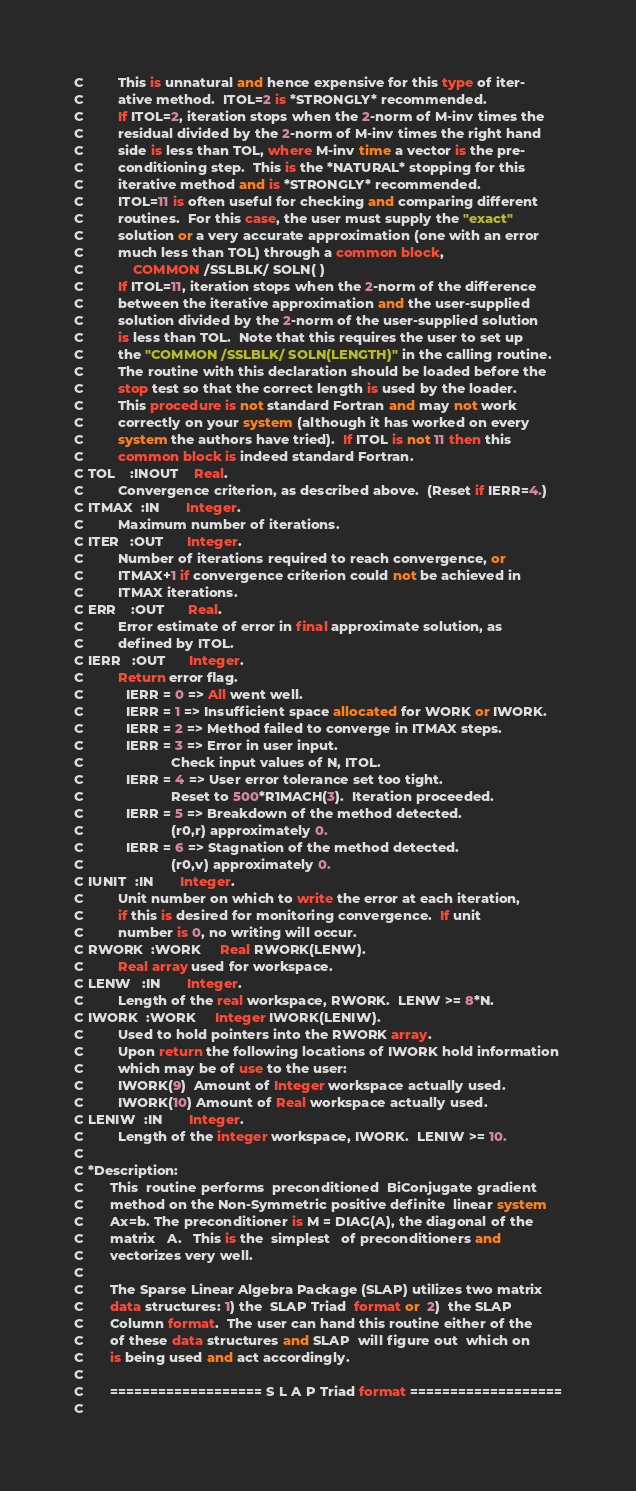Convert code to text. <code><loc_0><loc_0><loc_500><loc_500><_FORTRAN_>C         This is unnatural and hence expensive for this type of iter-
C         ative method.  ITOL=2 is *STRONGLY* recommended.
C         If ITOL=2, iteration stops when the 2-norm of M-inv times the
C         residual divided by the 2-norm of M-inv times the right hand
C         side is less than TOL, where M-inv time a vector is the pre-
C         conditioning step.  This is the *NATURAL* stopping for this
C         iterative method and is *STRONGLY* recommended.
C         ITOL=11 is often useful for checking and comparing different
C         routines.  For this case, the user must supply the "exact"
C         solution or a very accurate approximation (one with an error
C         much less than TOL) through a common block,
C             COMMON /SSLBLK/ SOLN( )
C         If ITOL=11, iteration stops when the 2-norm of the difference
C         between the iterative approximation and the user-supplied
C         solution divided by the 2-norm of the user-supplied solution
C         is less than TOL.  Note that this requires the user to set up
C         the "COMMON /SSLBLK/ SOLN(LENGTH)" in the calling routine.
C         The routine with this declaration should be loaded before the
C         stop test so that the correct length is used by the loader.
C         This procedure is not standard Fortran and may not work
C         correctly on your system (although it has worked on every
C         system the authors have tried).  If ITOL is not 11 then this
C         common block is indeed standard Fortran.
C TOL    :INOUT    Real.
C         Convergence criterion, as described above.  (Reset if IERR=4.)
C ITMAX  :IN       Integer.
C         Maximum number of iterations.
C ITER   :OUT      Integer.
C         Number of iterations required to reach convergence, or
C         ITMAX+1 if convergence criterion could not be achieved in
C         ITMAX iterations.
C ERR    :OUT      Real.
C         Error estimate of error in final approximate solution, as
C         defined by ITOL.
C IERR   :OUT      Integer.
C         Return error flag.
C           IERR = 0 => All went well.
C           IERR = 1 => Insufficient space allocated for WORK or IWORK.
C           IERR = 2 => Method failed to converge in ITMAX steps.
C           IERR = 3 => Error in user input.
C                       Check input values of N, ITOL.
C           IERR = 4 => User error tolerance set too tight.
C                       Reset to 500*R1MACH(3).  Iteration proceeded.
C           IERR = 5 => Breakdown of the method detected.
C                       (r0,r) approximately 0.
C           IERR = 6 => Stagnation of the method detected.
C                       (r0,v) approximately 0.
C IUNIT  :IN       Integer.
C         Unit number on which to write the error at each iteration,
C         if this is desired for monitoring convergence.  If unit
C         number is 0, no writing will occur.
C RWORK  :WORK     Real RWORK(LENW).
C         Real array used for workspace.
C LENW   :IN       Integer.
C         Length of the real workspace, RWORK.  LENW >= 8*N.
C IWORK  :WORK     Integer IWORK(LENIW).
C         Used to hold pointers into the RWORK array.
C         Upon return the following locations of IWORK hold information
C         which may be of use to the user:
C         IWORK(9)  Amount of Integer workspace actually used.
C         IWORK(10) Amount of Real workspace actually used.
C LENIW  :IN       Integer.
C         Length of the integer workspace, IWORK.  LENIW >= 10.
C
C *Description:
C       This  routine performs  preconditioned  BiConjugate gradient
C       method on the Non-Symmetric positive definite  linear system
C       Ax=b. The preconditioner is M = DIAG(A), the diagonal of the
C       matrix   A.   This is the  simplest   of preconditioners and
C       vectorizes very well.
C
C       The Sparse Linear Algebra Package (SLAP) utilizes two matrix
C       data structures: 1) the  SLAP Triad  format or  2)  the SLAP
C       Column format.  The user can hand this routine either of the
C       of these data structures and SLAP  will figure out  which on
C       is being used and act accordingly.
C
C       =================== S L A P Triad format ===================
C</code> 